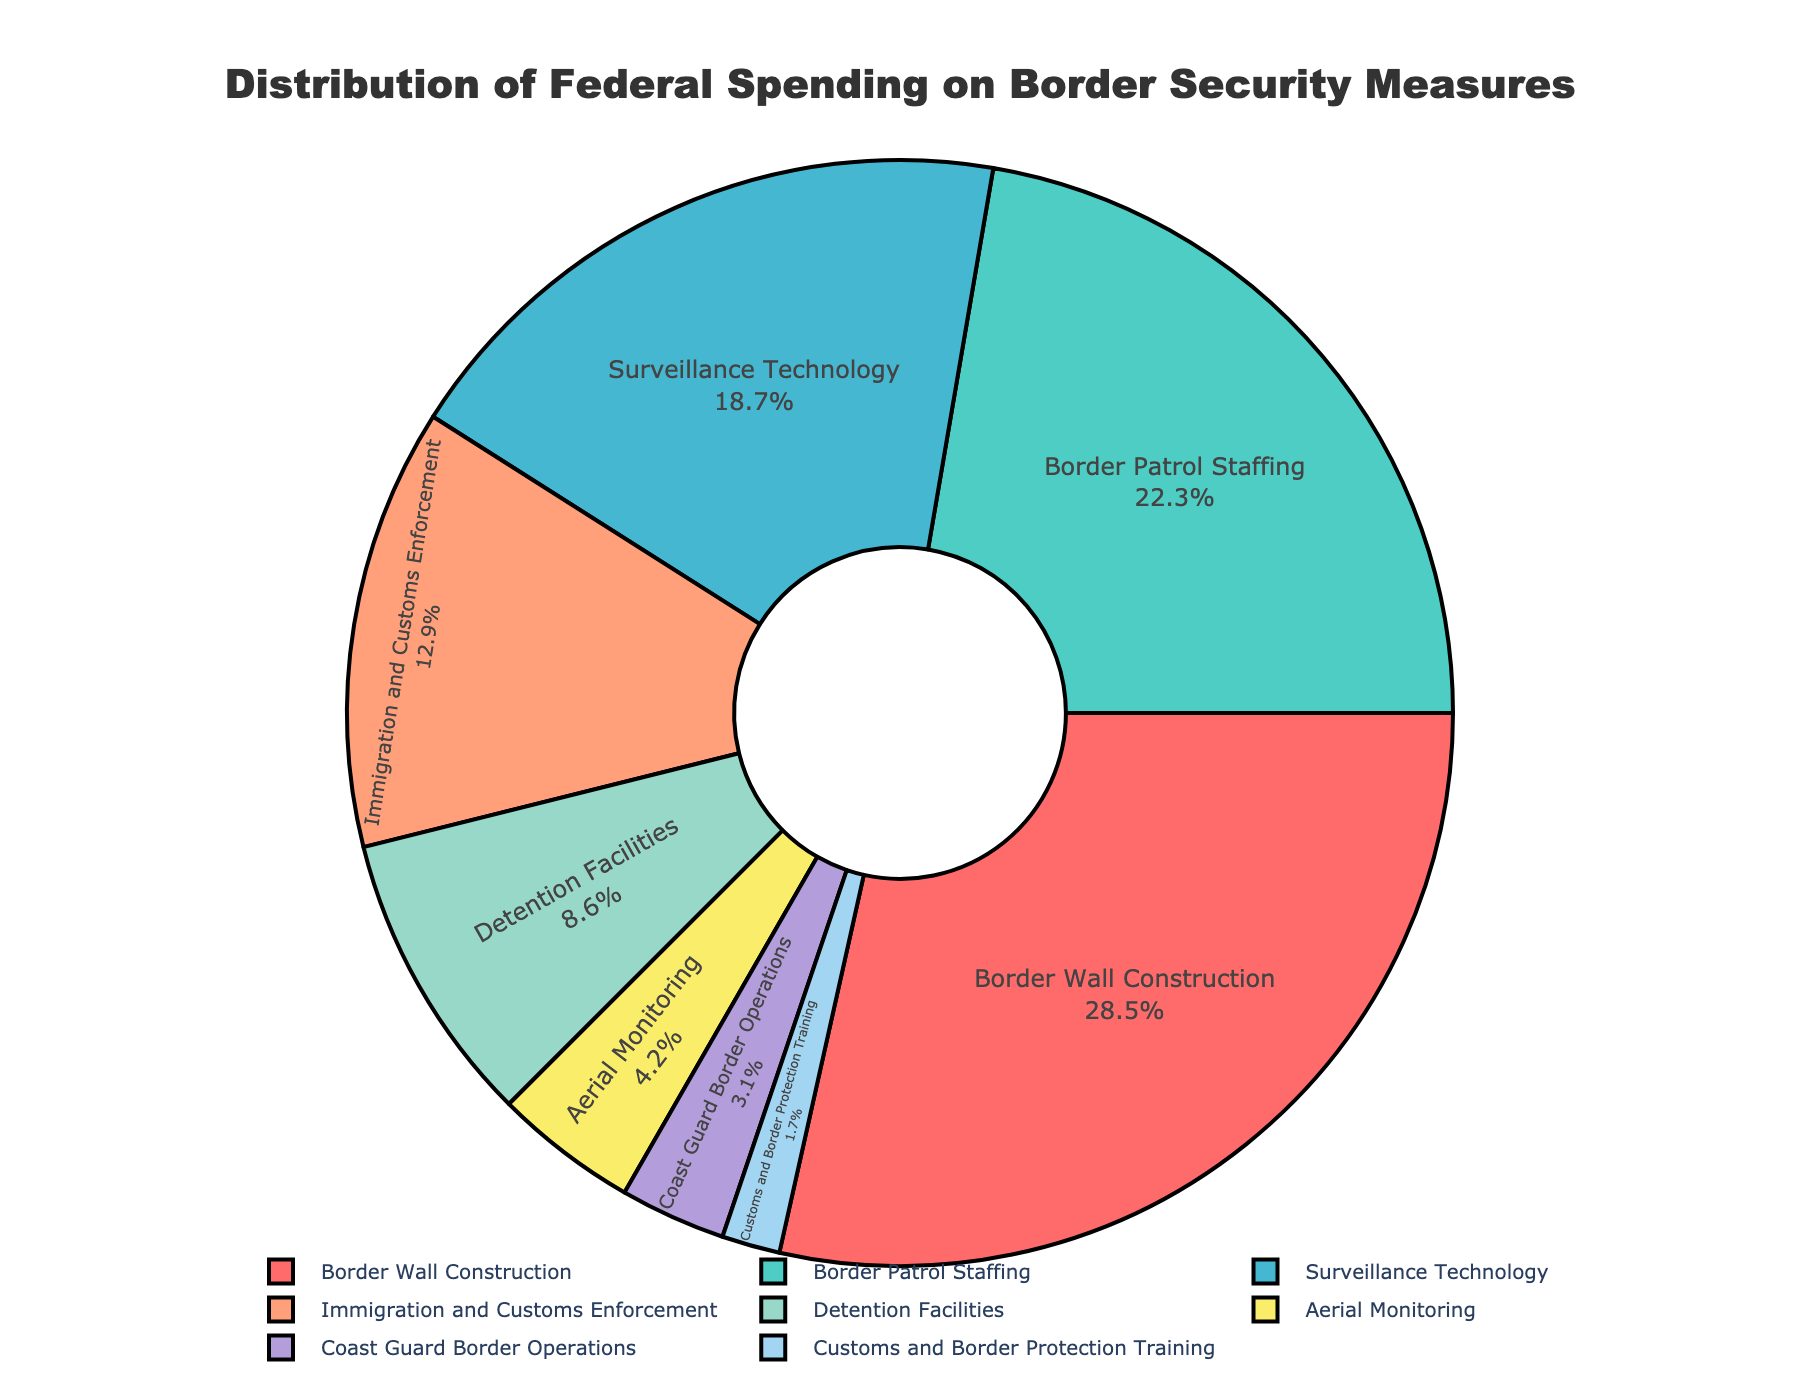What is the largest category of federal spending on border security? The largest category can be identified by the highest percentage shown in the pie chart, which is Border Wall Construction at 28.5%.
Answer: Border Wall Construction Which two categories combined make up more than 50% of the total spending? To find two categories that combined make up more than 50%, look for the two highest percentages and add them. Border Wall Construction (28.5%) + Border Patrol Staffing (22.3%) = 50.8%, which is more than 50%.
Answer: Border Wall Construction and Border Patrol Staffing How much more is spent on Border Wall Construction than on Immigration and Customs Enforcement? Calculate the difference between the percentages of Border Wall Construction (28.5%) and Immigration and Customs Enforcement (12.9%). 28.5% - 12.9% = 15.6%.
Answer: 15.6% If you combine the spending on Surveillance Technology and Detention Facilities, would it be higher than spending on Border Patrol Staffing? Add the percentages of Surveillance Technology (18.7%) and Detention Facilities (8.6%), then compare the sum to Border Patrol Staffing (22.3%). 18.7% + 8.6% = 27.3%, which is higher than 22.3%.
Answer: Yes Rank the categories by their spending from highest to lowest. Arrange the categories in descending order of their percentages. Border Wall Construction (28.5%), Border Patrol Staffing (22.3%), Surveillance Technology (18.7%), Immigration and Customs Enforcement (12.9%), Detention Facilities (8.6%), Aerial Monitoring (4.2%), Coast Guard Border Operations (3.1%), Customs and Border Protection Training (1.7%).
Answer: Border Wall Construction, Border Patrol Staffing, Surveillance Technology, Immigration and Customs Enforcement, Detention Facilities, Aerial Monitoring, Coast Guard Border Operations, Customs and Border Protection Training Which category has the smallest percentage of federal spending? Identify the category with the lowest percentage shown in the pie chart, which is Customs and Border Protection Training at 1.7%.
Answer: Customs and Border Protection Training Is the combined spending on Aerial Monitoring and Coast Guard Border Operations less than spending on Surveillance Technology? Add the percentages of Aerial Monitoring (4.2%) and Coast Guard Border Operations (3.1%), then compare the sum to Surveillance Technology (18.7%). 4.2% + 3.1% = 7.3%, which is less than 18.7%.
Answer: Yes What percentage of the total spending is dedicated to personnel-related categories (Border Patrol Staffing and Customs and Border Protection Training)? Add the percentages of Border Patrol Staffing (22.3%) and Customs and Border Protection Training (1.7%). 22.3% + 1.7% = 24%.
Answer: 24% How does the spending on Border Wall Construction compare to the combined spending on Detention Facilities and Aerial Monitoring? Compare the percentages: Border Wall Construction (28.5%) with the sum of Detention Facilities (8.6%) and Aerial Monitoring (4.2%). 8.6% + 4.2% = 12.8%. 28.5% is greater than 12.8%.
Answer: Border Wall Construction is higher 